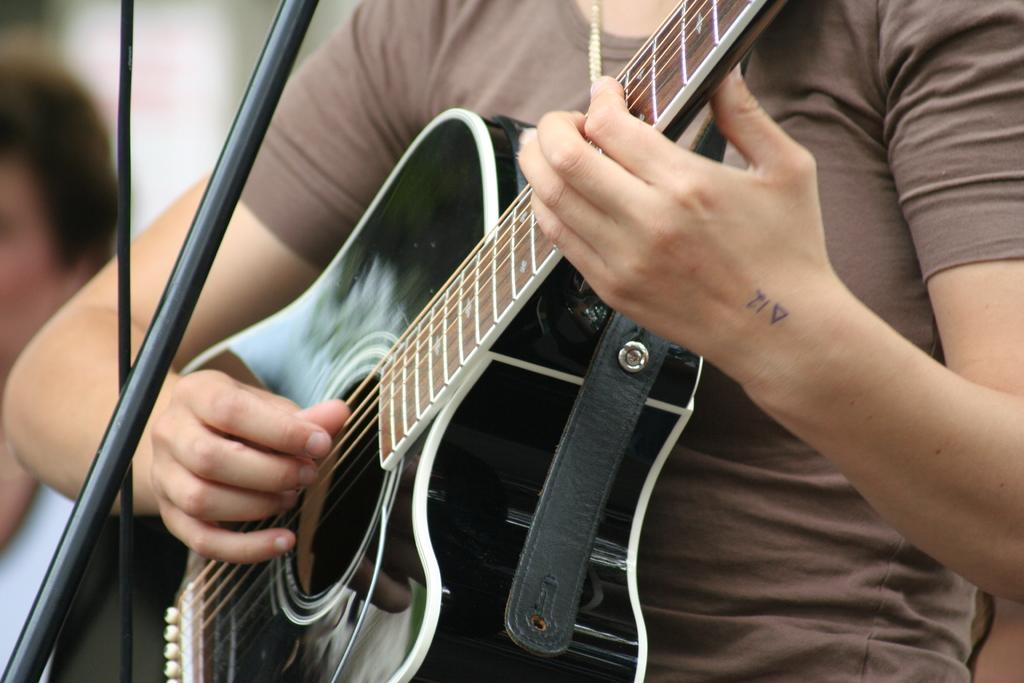What is the main subject of the image? There is a person in the image. What is the person holding in the image? The person is holding a guitar. Where is the throne located in the image? There is no throne present in the image. What is the relationship between the person and the grandfather in the image? There is no mention of a grandfather in the image, so we cannot determine any relationship. 